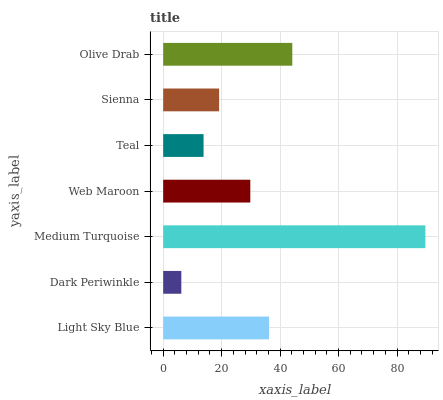Is Dark Periwinkle the minimum?
Answer yes or no. Yes. Is Medium Turquoise the maximum?
Answer yes or no. Yes. Is Medium Turquoise the minimum?
Answer yes or no. No. Is Dark Periwinkle the maximum?
Answer yes or no. No. Is Medium Turquoise greater than Dark Periwinkle?
Answer yes or no. Yes. Is Dark Periwinkle less than Medium Turquoise?
Answer yes or no. Yes. Is Dark Periwinkle greater than Medium Turquoise?
Answer yes or no. No. Is Medium Turquoise less than Dark Periwinkle?
Answer yes or no. No. Is Web Maroon the high median?
Answer yes or no. Yes. Is Web Maroon the low median?
Answer yes or no. Yes. Is Teal the high median?
Answer yes or no. No. Is Dark Periwinkle the low median?
Answer yes or no. No. 